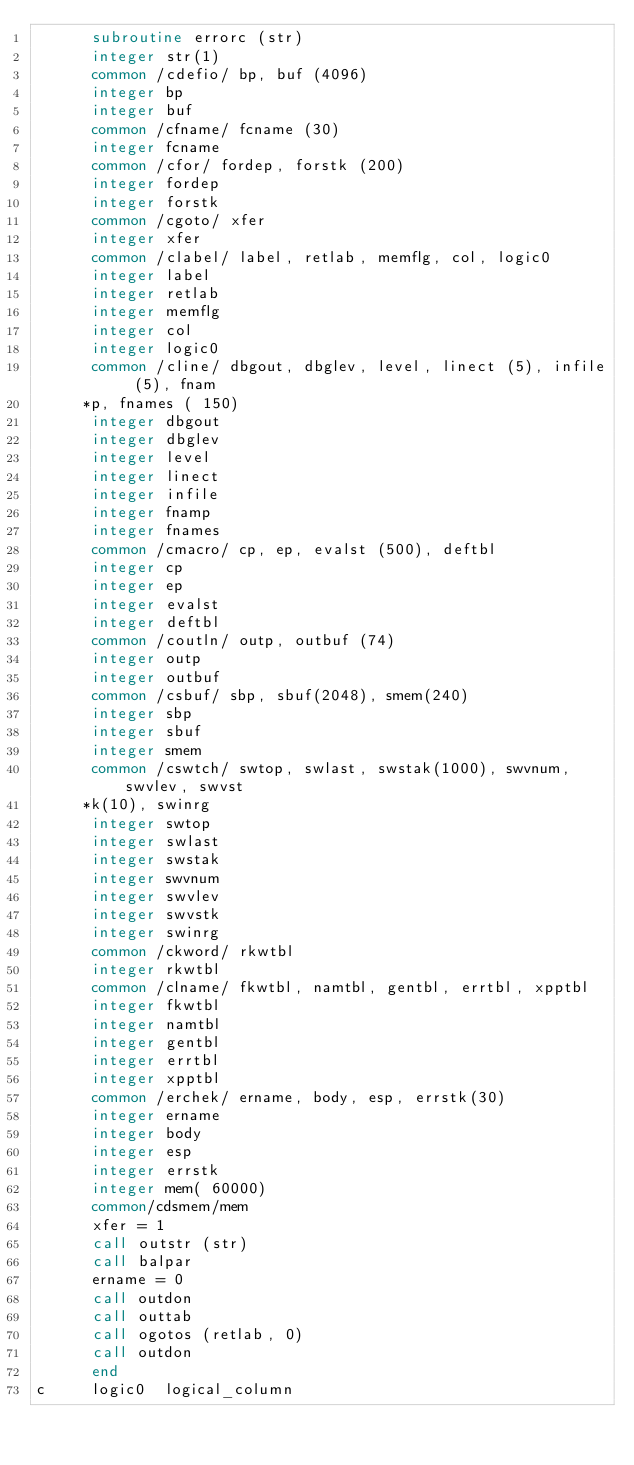<code> <loc_0><loc_0><loc_500><loc_500><_FORTRAN_>      subroutine errorc (str)
      integer str(1)
      common /cdefio/ bp, buf (4096)
      integer bp
      integer buf
      common /cfname/ fcname (30)
      integer fcname
      common /cfor/ fordep, forstk (200)
      integer fordep
      integer forstk
      common /cgoto/ xfer
      integer xfer
      common /clabel/ label, retlab, memflg, col, logic0
      integer label
      integer retlab
      integer memflg
      integer col
      integer logic0
      common /cline/ dbgout, dbglev, level, linect (5), infile (5), fnam
     *p, fnames ( 150)
      integer dbgout
      integer dbglev
      integer level
      integer linect
      integer infile
      integer fnamp
      integer fnames
      common /cmacro/ cp, ep, evalst (500), deftbl
      integer cp
      integer ep
      integer evalst
      integer deftbl
      common /coutln/ outp, outbuf (74)
      integer outp
      integer outbuf
      common /csbuf/ sbp, sbuf(2048), smem(240)
      integer sbp
      integer sbuf
      integer smem
      common /cswtch/ swtop, swlast, swstak(1000), swvnum, swvlev, swvst
     *k(10), swinrg
      integer swtop
      integer swlast
      integer swstak
      integer swvnum
      integer swvlev
      integer swvstk
      integer swinrg
      common /ckword/ rkwtbl
      integer rkwtbl
      common /clname/ fkwtbl, namtbl, gentbl, errtbl, xpptbl
      integer fkwtbl
      integer namtbl
      integer gentbl
      integer errtbl
      integer xpptbl
      common /erchek/ ername, body, esp, errstk(30)
      integer ername
      integer body
      integer esp
      integer errstk
      integer mem( 60000)
      common/cdsmem/mem
      xfer = 1
      call outstr (str)
      call balpar
      ername = 0
      call outdon
      call outtab
      call ogotos (retlab, 0)
      call outdon
      end
c     logic0  logical_column
</code> 